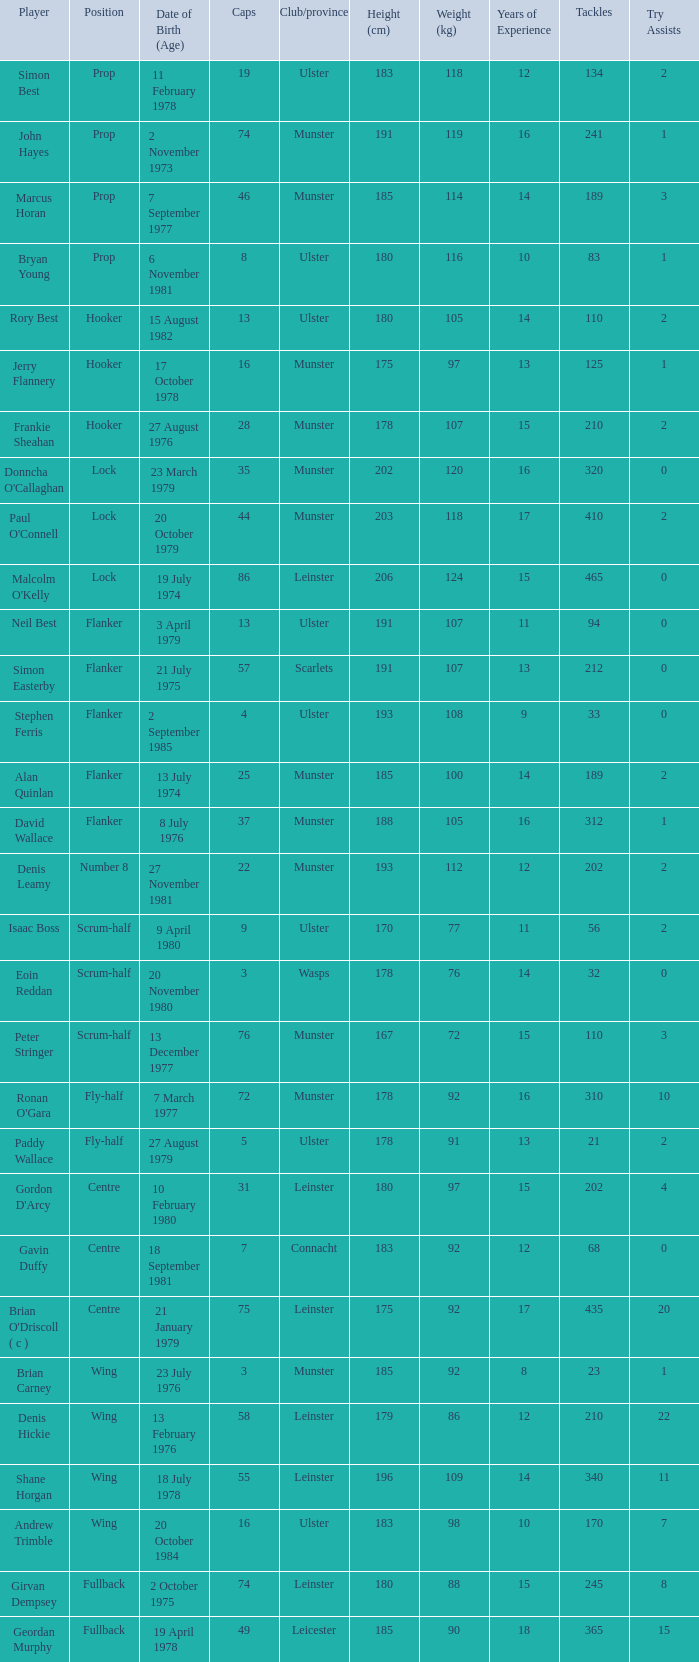What is the club or province of Girvan Dempsey, who has 74 caps? Leinster. 